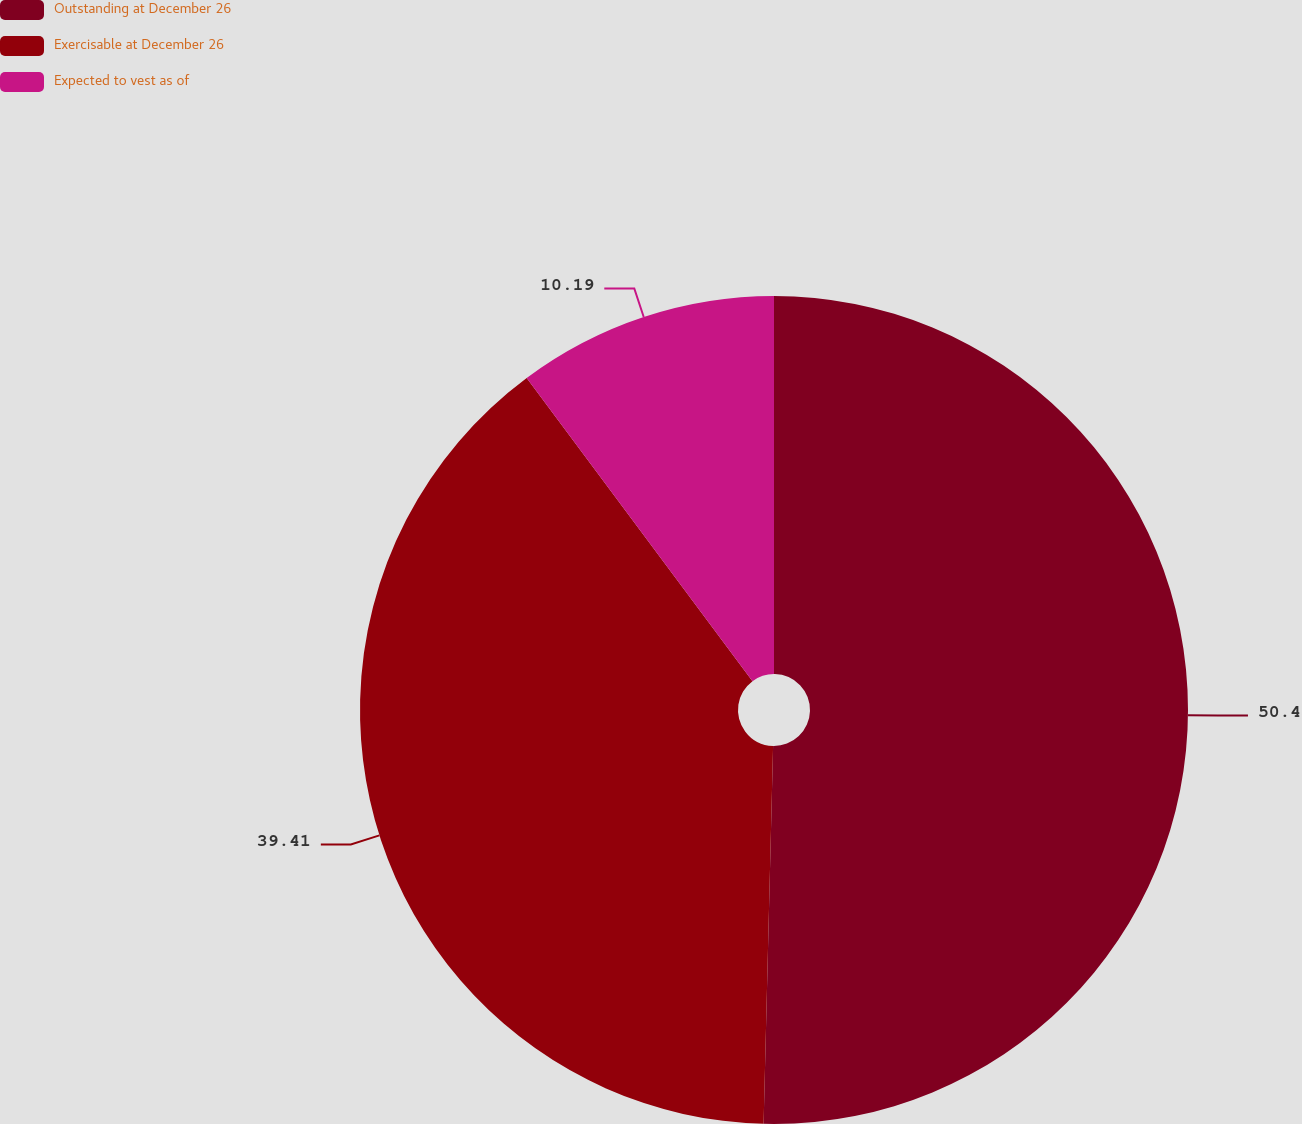Convert chart to OTSL. <chart><loc_0><loc_0><loc_500><loc_500><pie_chart><fcel>Outstanding at December 26<fcel>Exercisable at December 26<fcel>Expected to vest as of<nl><fcel>50.4%<fcel>39.41%<fcel>10.19%<nl></chart> 